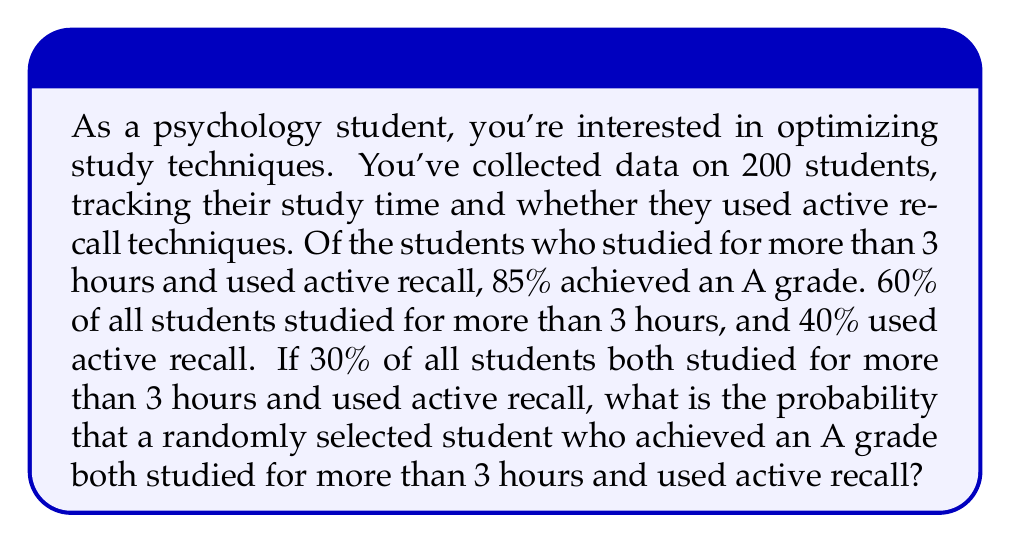Can you solve this math problem? Let's approach this step-by-step using Bayes' theorem:

1) Define events:
   A: Student achieved an A grade
   B: Student studied > 3 hours and used active recall

2) Given information:
   P(A|B) = 0.85 (probability of A given B)
   P(B) = 0.30 (probability of B)

3) We need to find P(B|A) (probability of B given A)

4) Bayes' theorem states:

   $$P(B|A) = \frac{P(A|B) \cdot P(B)}{P(A)}$$

5) We know P(A|B) and P(B), but we need to calculate P(A)

6) We can use the law of total probability:
   
   $$P(A) = P(A|B) \cdot P(B) + P(A|\text{not B}) \cdot P(\text{not B})$$

7) We know P(A|B), P(B), and P(not B) = 1 - P(B) = 0.70

8) We need to estimate P(A|not B). Let's assume it's lower, say 0.40

9) Now we can calculate P(A):

   $$P(A) = 0.85 \cdot 0.30 + 0.40 \cdot 0.70 = 0.255 + 0.280 = 0.535$$

10) Now we can use Bayes' theorem:

    $$P(B|A) = \frac{0.85 \cdot 0.30}{0.535} = \frac{0.255}{0.535} \approx 0.4766$$

11) Convert to a percentage: 0.4766 * 100 ≈ 47.66%
Answer: 47.66% 